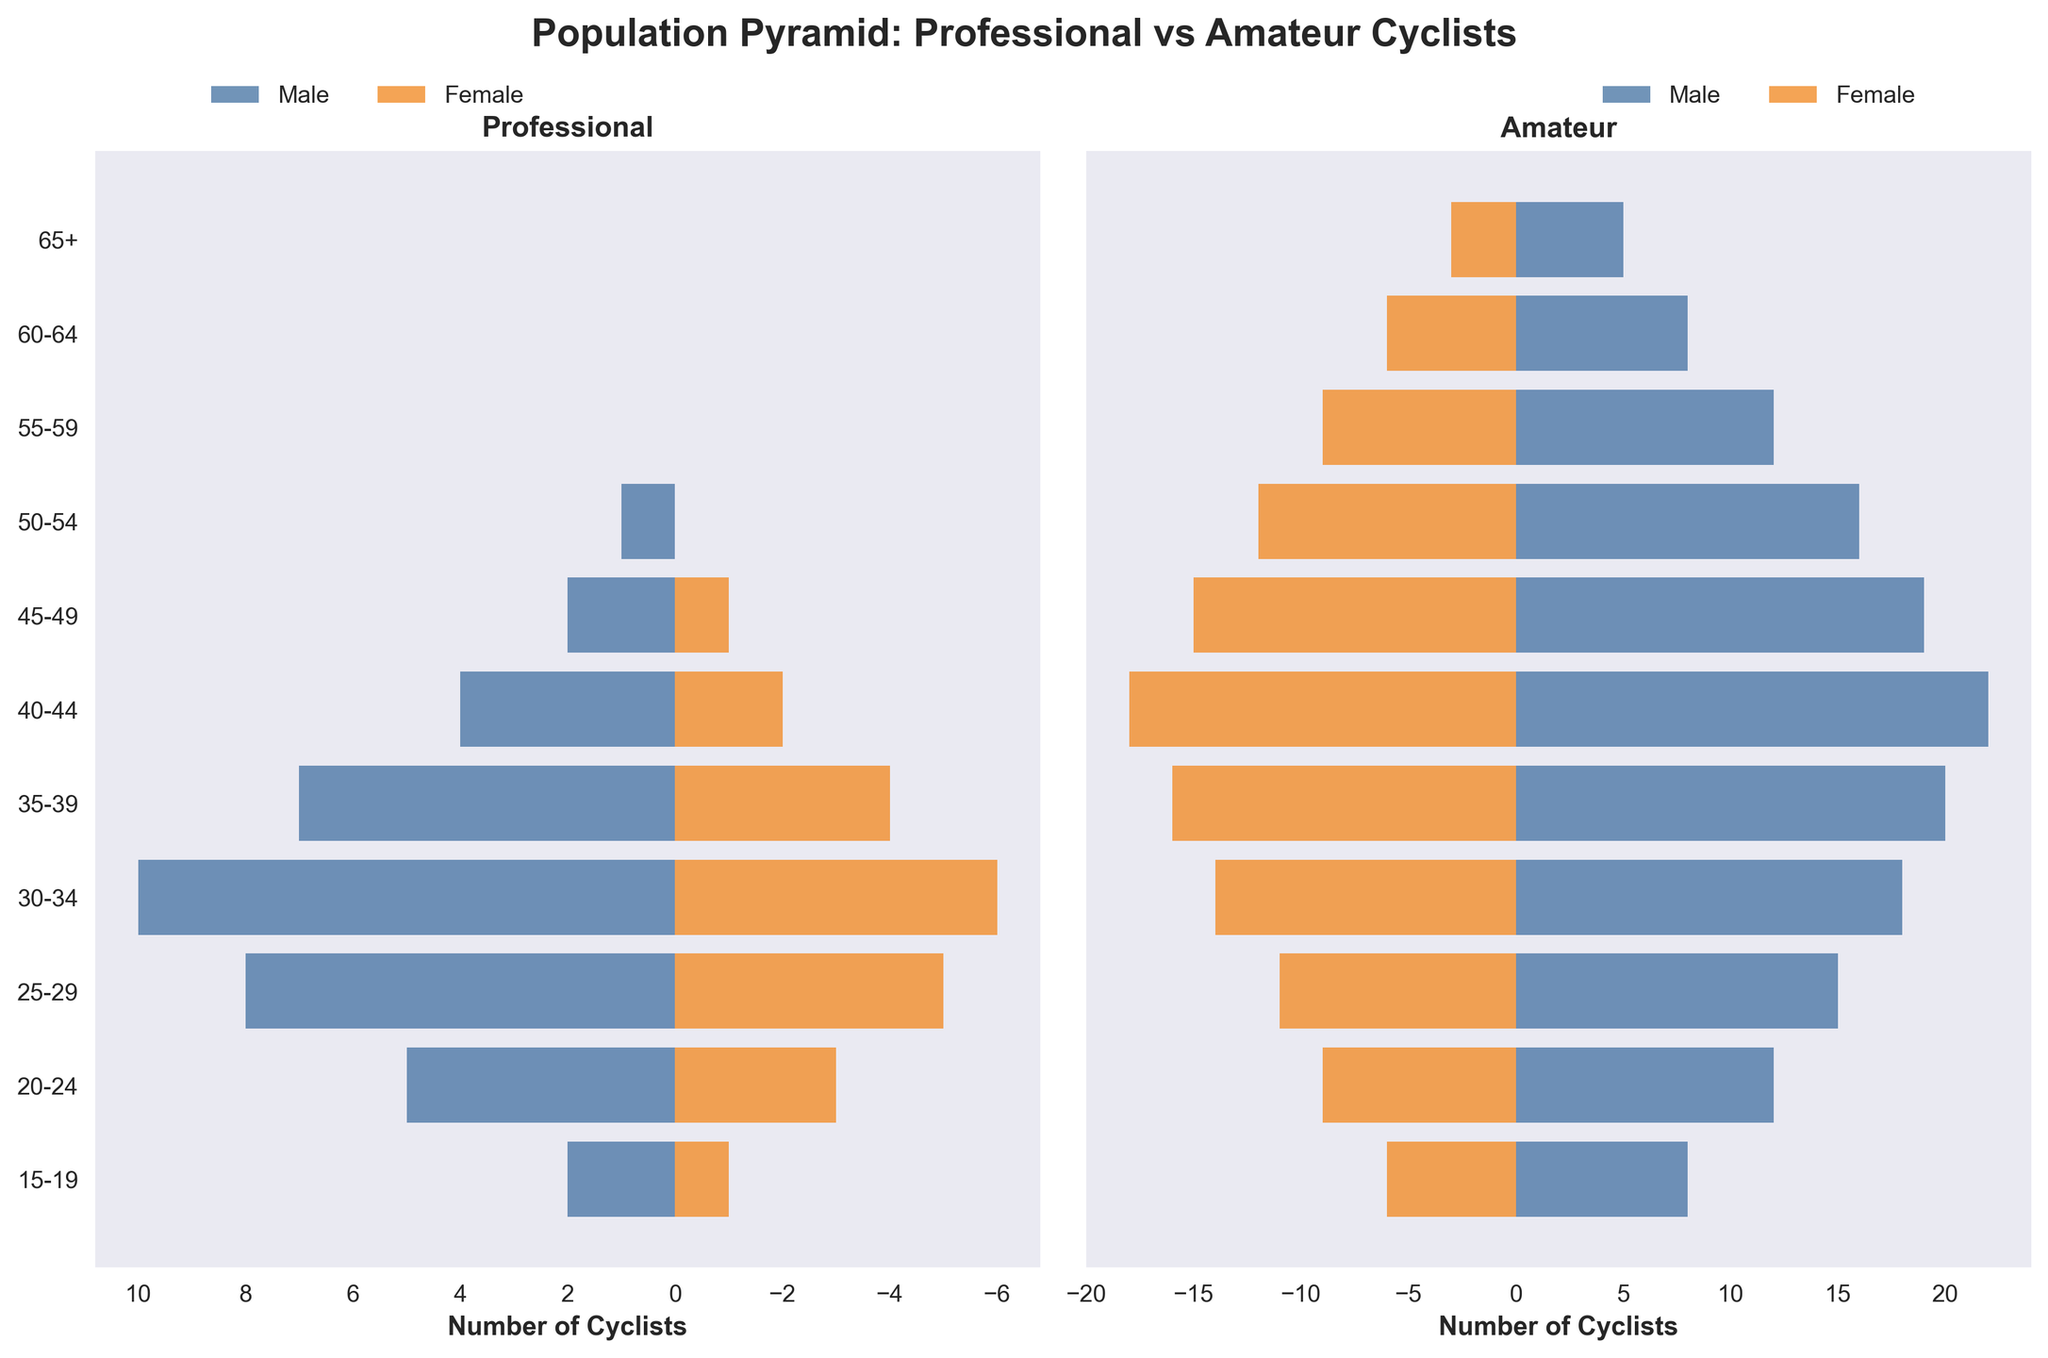What is the title of the figure? The title of the figure is displayed prominently at the top. It reads "Population Pyramid: Professional vs Amateur Cyclists".
Answer: Population Pyramid: Professional vs Amateur Cyclists What age group has the highest number of professional male cyclists? By examining the left-side bar chart for professional cyclists, we see the tallest bar in blue. This corresponds to the "30-34" age group.
Answer: 30-34 How many female amateur cyclists are in the 45-49 age group? On the right-side bar chart for amateurs, the orange bar opposite the '45-49' age label indicates the number of female cyclists. This bar extends to the value '15'.
Answer: 15 What is the combined number of male and female professional cyclists in the 25-29 age group? To find this, locate the values of both the male and female professional cyclists in the "25-29" age group and add them together: (8 + 5).
Answer: 13 Which age group has more female amateur cyclists compared to female professional cyclists? Compare each age group's orange bars for professionals and amateurs. This difference is evident in almost each age group, but notably higher in "45-49" where the difference is 15 (15 - 1).
Answer: 45-49 Which group has a higher number of cyclists aged 40-44, male amateurs or male professionals? Compare the lengths of the blue bars for amateurs and professionals within the "40-44" age group. The amateurs have a longer bar (22 vs. 4).
Answer: Male amateurs What is the total number of amateur cyclists in the 50-54 age group? Add the values for both male and female amateur cyclists in this age group: (16 + 12).
Answer: 28 How many age groups have zero female professional cyclists? Look at the left-side chart for professionals. The orange bars for certain age groups, namely "50-54", "55-59", "60-64", and "65+", have zero values. There are 4 such age groups.
Answer: 4 Among the 35-39 age group, which gender has more amateur cyclists? On the right-side bar chart, compare the lengths of the blue and orange bars. The blue bar (male) is longer than the orange bar (female).
Answer: Male 